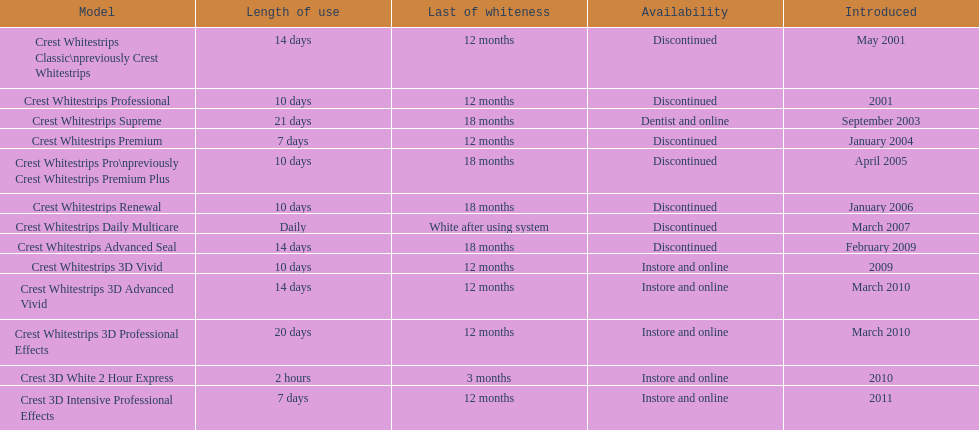Which product was to be used longer, crest whitestrips classic or crest whitestrips 3d vivid? Crest Whitestrips Classic. 